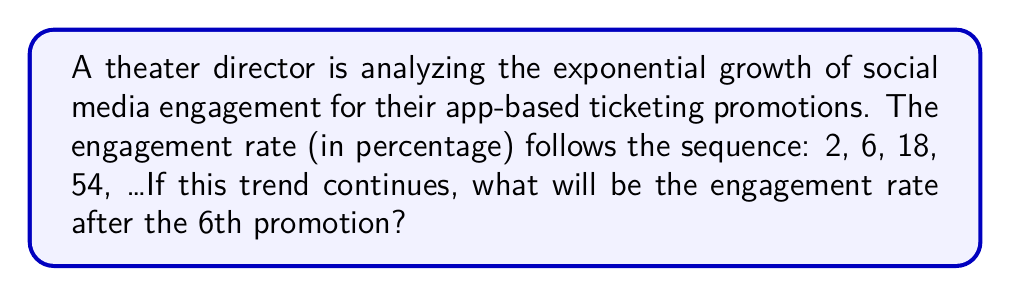Could you help me with this problem? Let's approach this step-by-step:

1) First, we need to identify the pattern in the given sequence:
   2, 6, 18, 54, ...

2) We can see that each term is being multiplied by a constant factor to get the next term:
   6 ÷ 2 = 3
   18 ÷ 6 = 3
   54 ÷ 18 = 3

3) This confirms that we have an exponential sequence with a common ratio of 3.

4) We can express this sequence mathematically as:
   $a_n = a_1 \cdot r^{n-1}$
   Where $a_n$ is the nth term, $a_1$ is the first term, r is the common ratio, and n is the position of the term.

5) In this case:
   $a_1 = 2$ (first term)
   $r = 3$ (common ratio)

6) We want to find the 6th term, so n = 6:
   $a_6 = 2 \cdot 3^{6-1} = 2 \cdot 3^5$

7) Let's calculate this:
   $2 \cdot 3^5 = 2 \cdot 243 = 486$

Therefore, after the 6th promotion, the engagement rate will be 486%.
Answer: 486% 